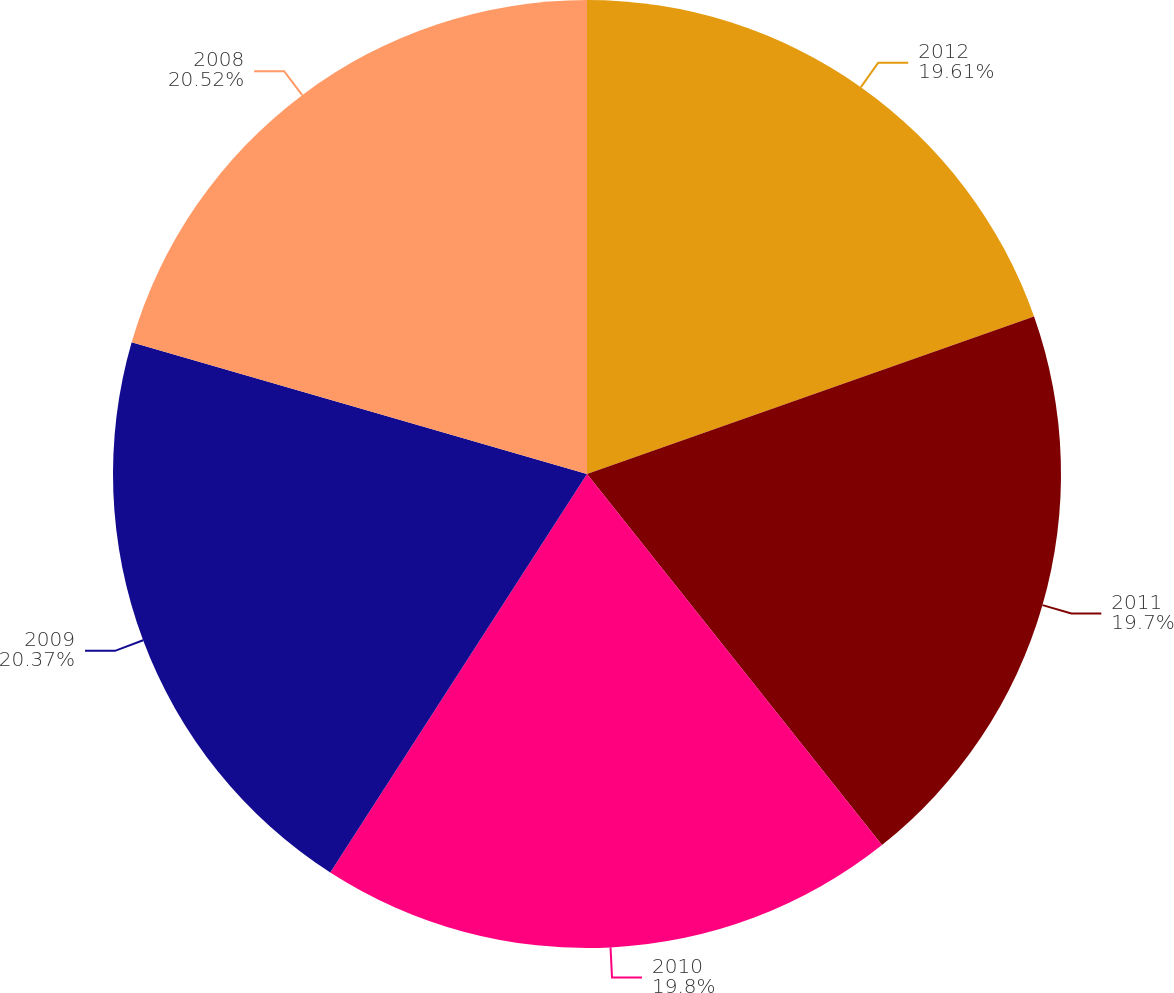Convert chart. <chart><loc_0><loc_0><loc_500><loc_500><pie_chart><fcel>2012<fcel>2011<fcel>2010<fcel>2009<fcel>2008<nl><fcel>19.61%<fcel>19.7%<fcel>19.8%<fcel>20.37%<fcel>20.52%<nl></chart> 